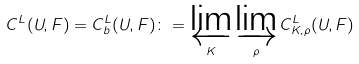Convert formula to latex. <formula><loc_0><loc_0><loc_500><loc_500>C ^ { L } ( U , F ) = C _ { b } ^ { L } ( U , F ) \colon = \varprojlim _ { K } \varinjlim _ { \rho } C ^ { L } _ { K , \rho } ( U , F )</formula> 